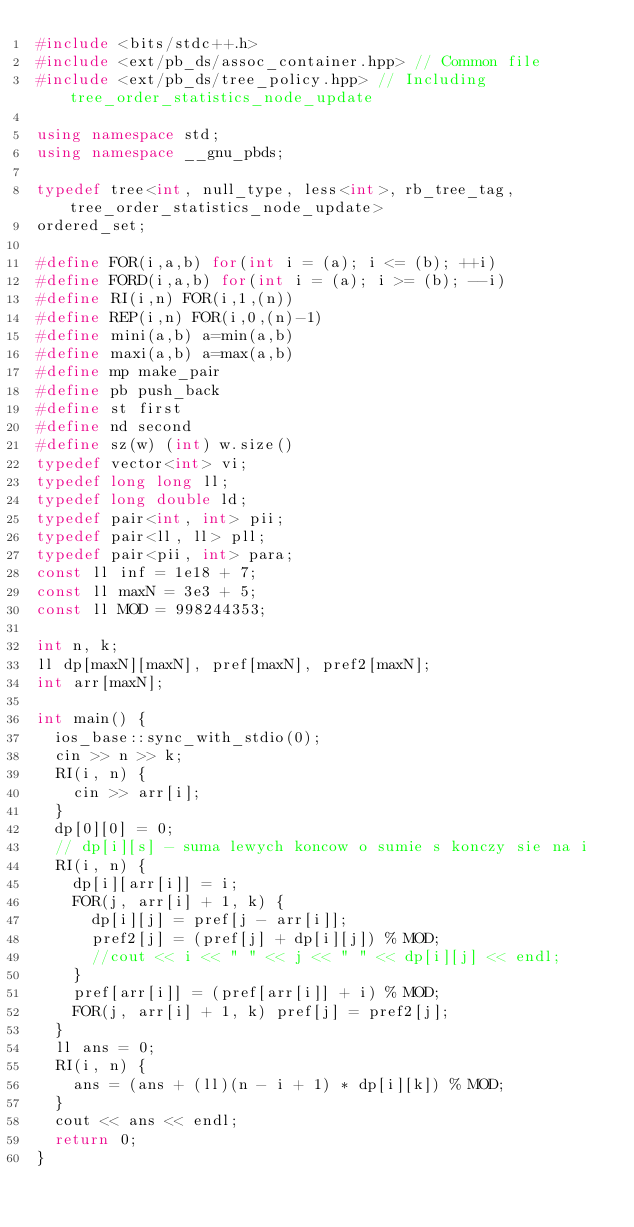<code> <loc_0><loc_0><loc_500><loc_500><_C++_>#include <bits/stdc++.h>
#include <ext/pb_ds/assoc_container.hpp> // Common file
#include <ext/pb_ds/tree_policy.hpp> // Including tree_order_statistics_node_update

using namespace std;
using namespace __gnu_pbds;

typedef tree<int, null_type, less<int>, rb_tree_tag, tree_order_statistics_node_update>
ordered_set;	

#define FOR(i,a,b) for(int i = (a); i <= (b); ++i)
#define FORD(i,a,b) for(int i = (a); i >= (b); --i)
#define RI(i,n) FOR(i,1,(n))
#define REP(i,n) FOR(i,0,(n)-1)
#define mini(a,b) a=min(a,b)
#define maxi(a,b) a=max(a,b)
#define mp make_pair
#define pb push_back
#define st first
#define nd second
#define sz(w) (int) w.size()
typedef vector<int> vi;
typedef long long ll;
typedef long double ld;
typedef pair<int, int> pii;
typedef pair<ll, ll> pll;
typedef pair<pii, int> para;
const ll inf = 1e18 + 7;
const ll maxN = 3e3 + 5;
const ll MOD = 998244353;

int n, k;
ll dp[maxN][maxN], pref[maxN], pref2[maxN];
int arr[maxN];

int main() {
	ios_base::sync_with_stdio(0);
	cin >> n >> k;
	RI(i, n) {
		cin >> arr[i];
	}
	dp[0][0] = 0;
	// dp[i][s] - suma lewych koncow o sumie s konczy sie na i
	RI(i, n) {
		dp[i][arr[i]] = i;
		FOR(j, arr[i] + 1, k) {
			dp[i][j] = pref[j - arr[i]];
			pref2[j] = (pref[j] + dp[i][j]) % MOD;
			//cout << i << " " << j << " " << dp[i][j] << endl;
		}
		pref[arr[i]] = (pref[arr[i]] + i) % MOD;
		FOR(j, arr[i] + 1, k) pref[j] = pref2[j];
	}
	ll ans = 0;
	RI(i, n) {
		ans = (ans + (ll)(n - i + 1) * dp[i][k]) % MOD;
	}	
	cout << ans << endl;
	return 0;
}
 
</code> 